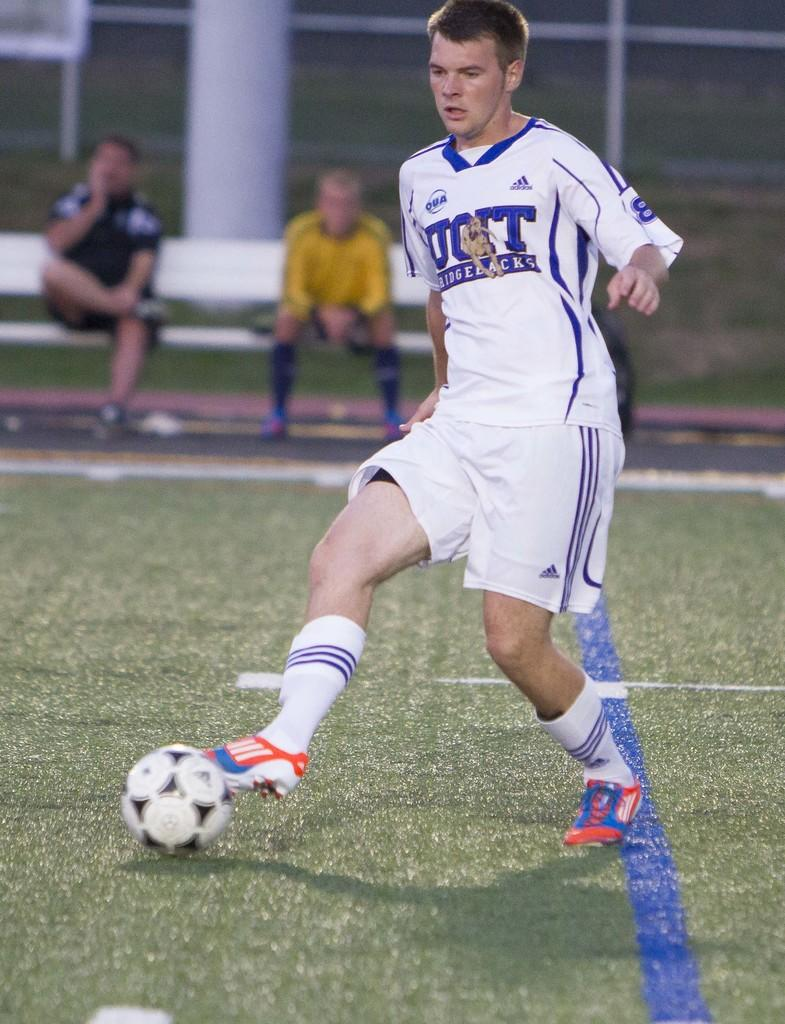<image>
Share a concise interpretation of the image provided. A Ridgebacks soccer player kicking a ball in a white and blue uniform 